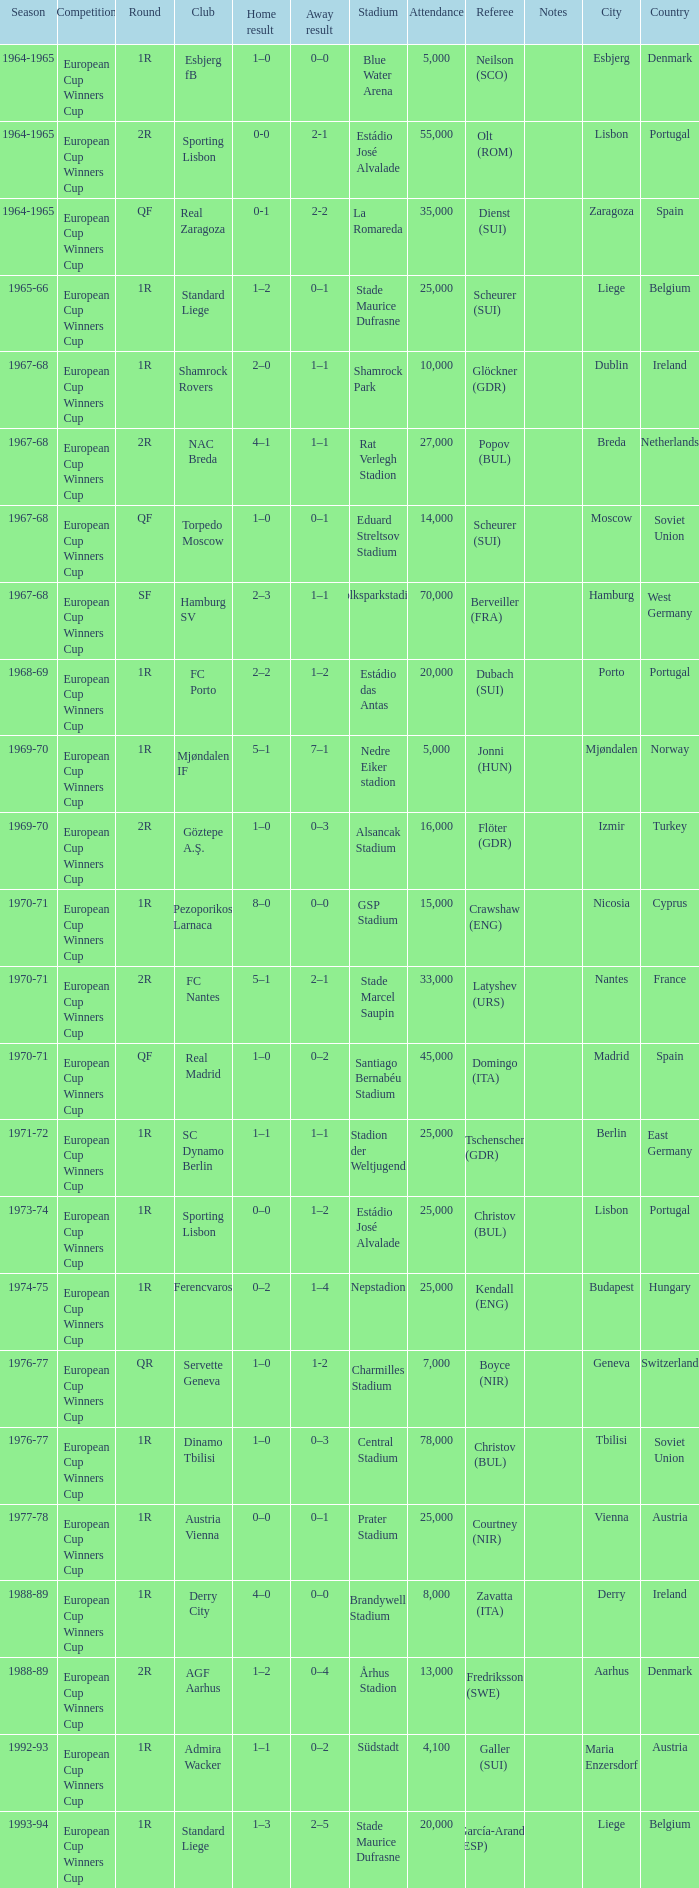Round of 2r, and a Home result of 0-0 has what season? 1964-1965. 